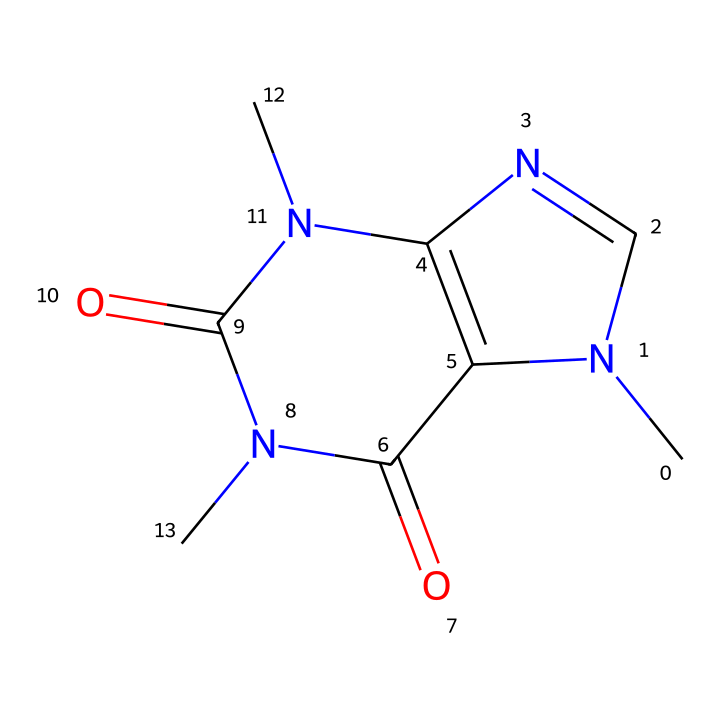What is the molecular formula of caffeine? To determine the molecular formula from the SMILES representation, we identify each type of atom present. The structure contains carbon (C), nitrogen (N), and oxygen (O). Counting the atoms, we find 8 carbon atoms, 10 hydrogen atoms, 4 nitrogen atoms, and 2 oxygen atoms, summing it up to C8H10N4O2.
Answer: C8H10N4O2 How many nitrogen atoms are in the caffeine structure? By examining the SMILES representation, we can see the nitrogen atoms labeled as "N". Counting these, we find there are 4 nitrogen atoms present in the caffeine structure.
Answer: 4 What type of chemical structure is caffeine? Caffeine is classified as an alkaloid due to the presence of nitrogen atoms and its biological activity. Alkaloids are a group of naturally occurring compounds that mostly contain basic nitrogen atoms. This structure's nitrogen content confirms caffeine's classification as an alkaloid.
Answer: alkaloid Does caffeine contain any acidic functional groups? Looking at the chemical structure, we don't observe any carboxylic acid (-COOH) or sulfonic acid (-SO3H) groups, which are typical for acids. The presence of the carbonyl group (C=O) is not classified as an acidic functional group but rather suggests that caffeine behaves more as a neutral molecule than an acid.
Answer: no How many rings are present in the structure of caffeine? Analyzing the SMILES representation, we notice two distinct ring structures. The presence of "N1" and "C2" indicates that these atoms are part of cyclic structures. After examination, we can confirm that there are two interconnected ring structures in caffeine.
Answer: 2 What is the significance of the nitrogen atoms in caffeine? The nitrogen atoms in caffeine contribute to its stimulant properties. They play a crucial role in the interaction with adenosine receptors in the brain, leading to increased alertness. Additionally, the nitrogen atoms also contribute to caffeine's classification as an alkaloid.
Answer: stimulant properties 